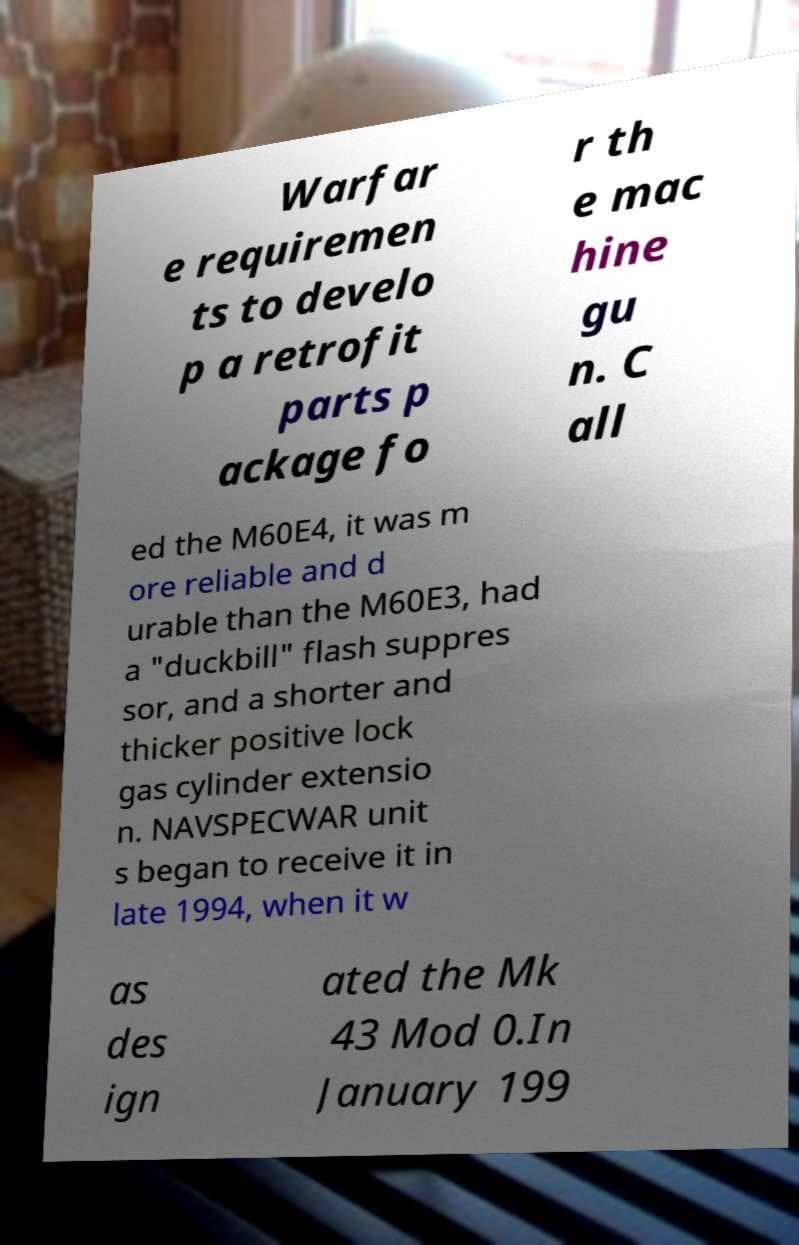What messages or text are displayed in this image? I need them in a readable, typed format. Warfar e requiremen ts to develo p a retrofit parts p ackage fo r th e mac hine gu n. C all ed the M60E4, it was m ore reliable and d urable than the M60E3, had a "duckbill" flash suppres sor, and a shorter and thicker positive lock gas cylinder extensio n. NAVSPECWAR unit s began to receive it in late 1994, when it w as des ign ated the Mk 43 Mod 0.In January 199 